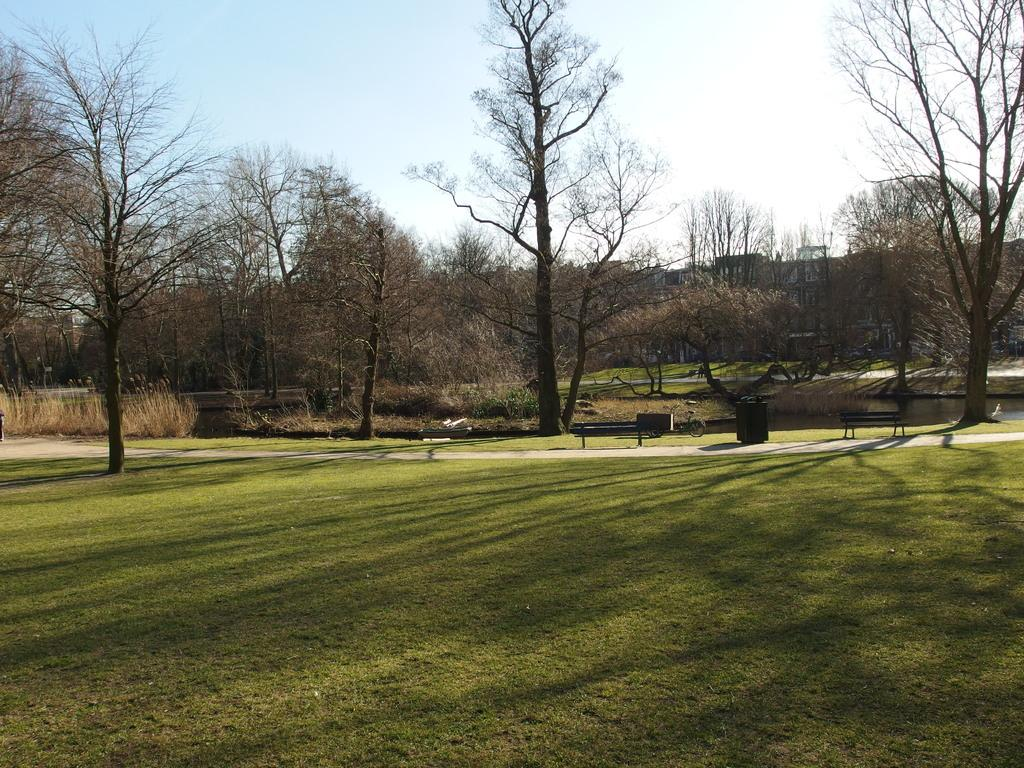What type of environment is depicted in the image? The image is an outside view. What type of vegetation is visible at the bottom of the image? There is grass at the bottom of the image. What can be seen in the background of the image? There are many trees in the background of the image. What type of seating is present in the image? There is a bench on the ground in the image. What is visible at the top of the image? The sky is visible at the top of the image. What type of soup is being served on the bench in the image? There is no soup present in the image; it features an outside view with grass, trees, and a bench. What hand gesture is being made by the trees in the background? There are no hand gestures made by the trees in the image, as trees are not capable of making hand gestures. 